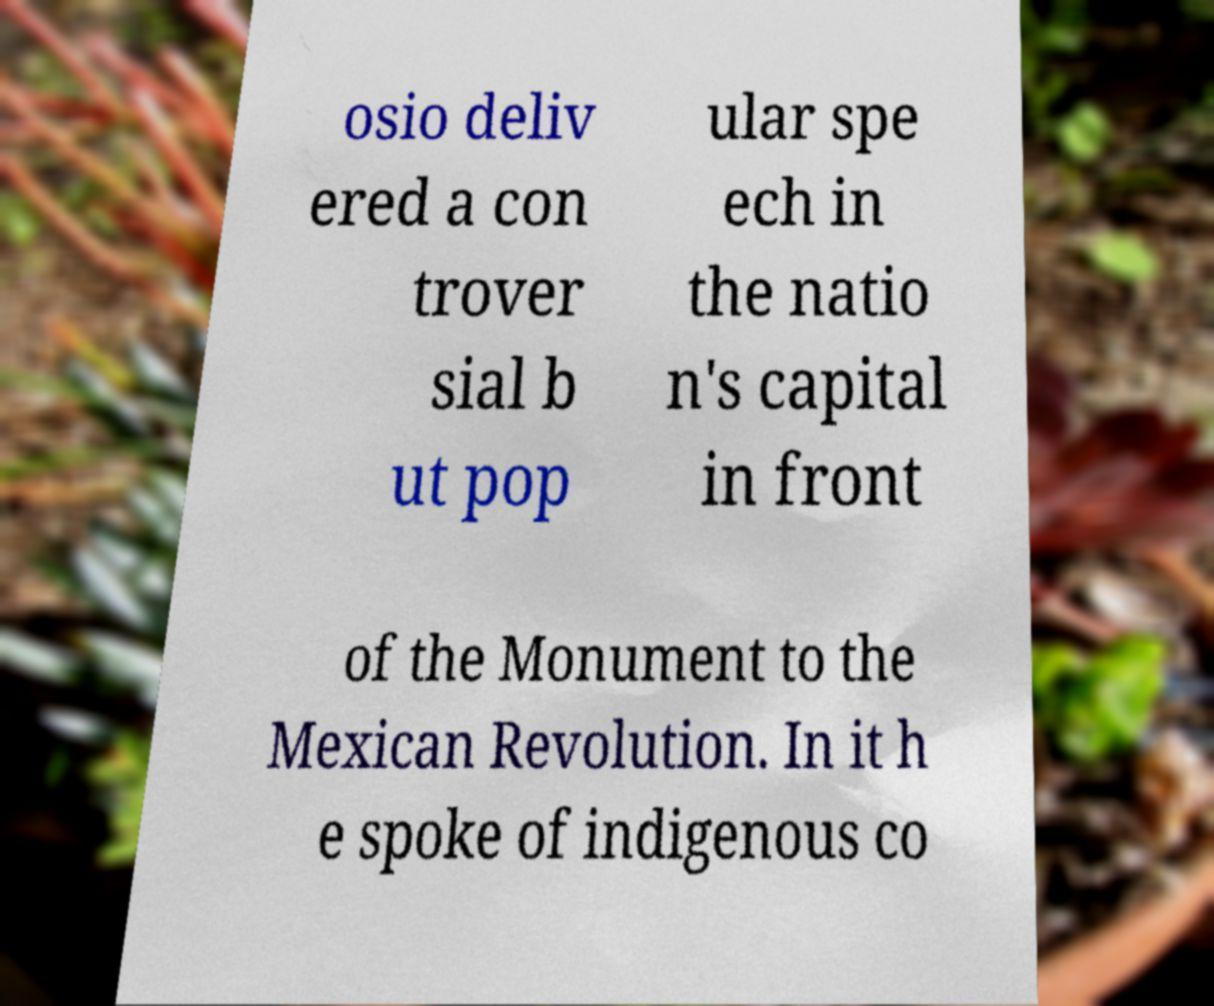Could you assist in decoding the text presented in this image and type it out clearly? osio deliv ered a con trover sial b ut pop ular spe ech in the natio n's capital in front of the Monument to the Mexican Revolution. In it h e spoke of indigenous co 